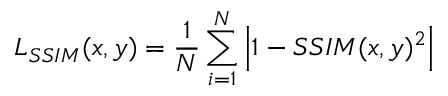<formula> <loc_0><loc_0><loc_500><loc_500>L _ { S S I M } ( x , y ) = \frac { 1 } { N } \sum _ { i = 1 } ^ { N } \left | 1 - S S I M ( x , y ) ^ { 2 } \right |</formula> 